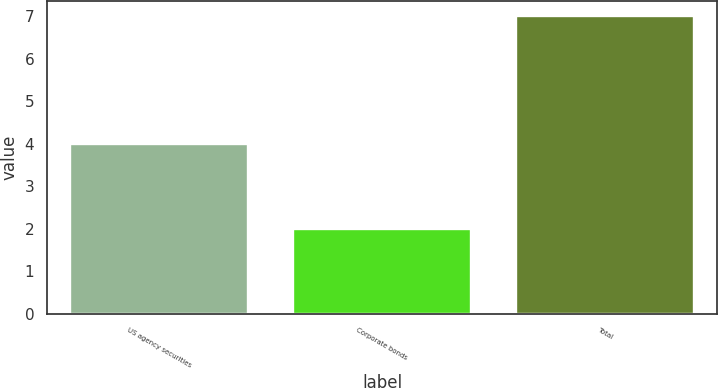Convert chart. <chart><loc_0><loc_0><loc_500><loc_500><bar_chart><fcel>US agency securities<fcel>Corporate bonds<fcel>Total<nl><fcel>4<fcel>2<fcel>7<nl></chart> 